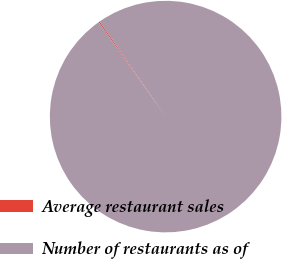Convert chart to OTSL. <chart><loc_0><loc_0><loc_500><loc_500><pie_chart><fcel>Average restaurant sales<fcel>Number of restaurants as of<nl><fcel>0.17%<fcel>99.83%<nl></chart> 